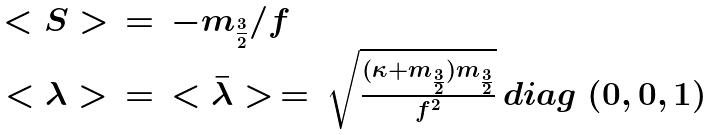<formula> <loc_0><loc_0><loc_500><loc_500>\begin{array} { c c l } { < S > } & { = } & { { - m _ { \frac { 3 } { 2 } } / f \strut } } \\ { < \lambda > } & { = } & { { < \bar { \lambda } > \, = \, \sqrt { { \frac { ( \kappa + m _ { \frac { 3 } { 2 } } ) m _ { \frac { 3 } { 2 } } } { f ^ { 2 } } } } \, d i a g \ ( 0 , 0 , 1 ) } } \end{array}</formula> 